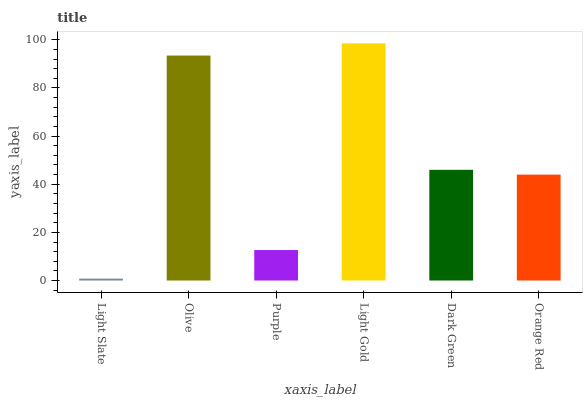Is Light Slate the minimum?
Answer yes or no. Yes. Is Light Gold the maximum?
Answer yes or no. Yes. Is Olive the minimum?
Answer yes or no. No. Is Olive the maximum?
Answer yes or no. No. Is Olive greater than Light Slate?
Answer yes or no. Yes. Is Light Slate less than Olive?
Answer yes or no. Yes. Is Light Slate greater than Olive?
Answer yes or no. No. Is Olive less than Light Slate?
Answer yes or no. No. Is Dark Green the high median?
Answer yes or no. Yes. Is Orange Red the low median?
Answer yes or no. Yes. Is Orange Red the high median?
Answer yes or no. No. Is Light Gold the low median?
Answer yes or no. No. 